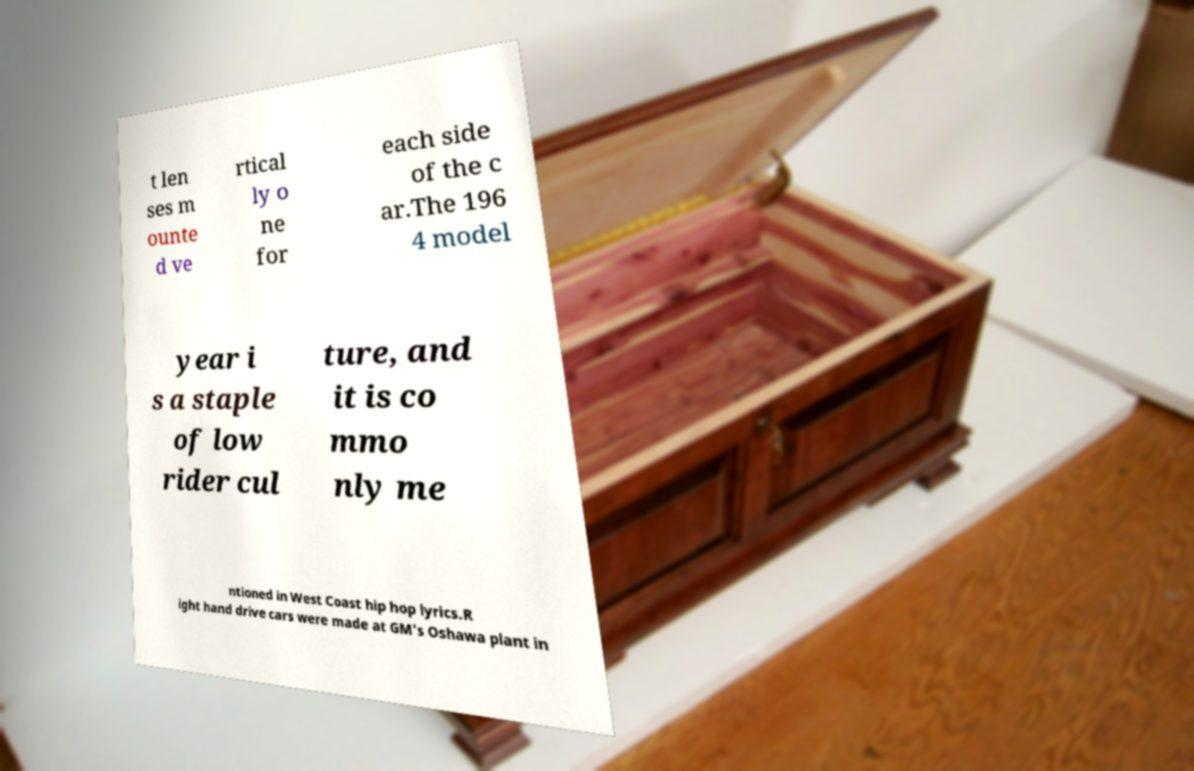What messages or text are displayed in this image? I need them in a readable, typed format. t len ses m ounte d ve rtical ly o ne for each side of the c ar.The 196 4 model year i s a staple of low rider cul ture, and it is co mmo nly me ntioned in West Coast hip hop lyrics.R ight hand drive cars were made at GM's Oshawa plant in 